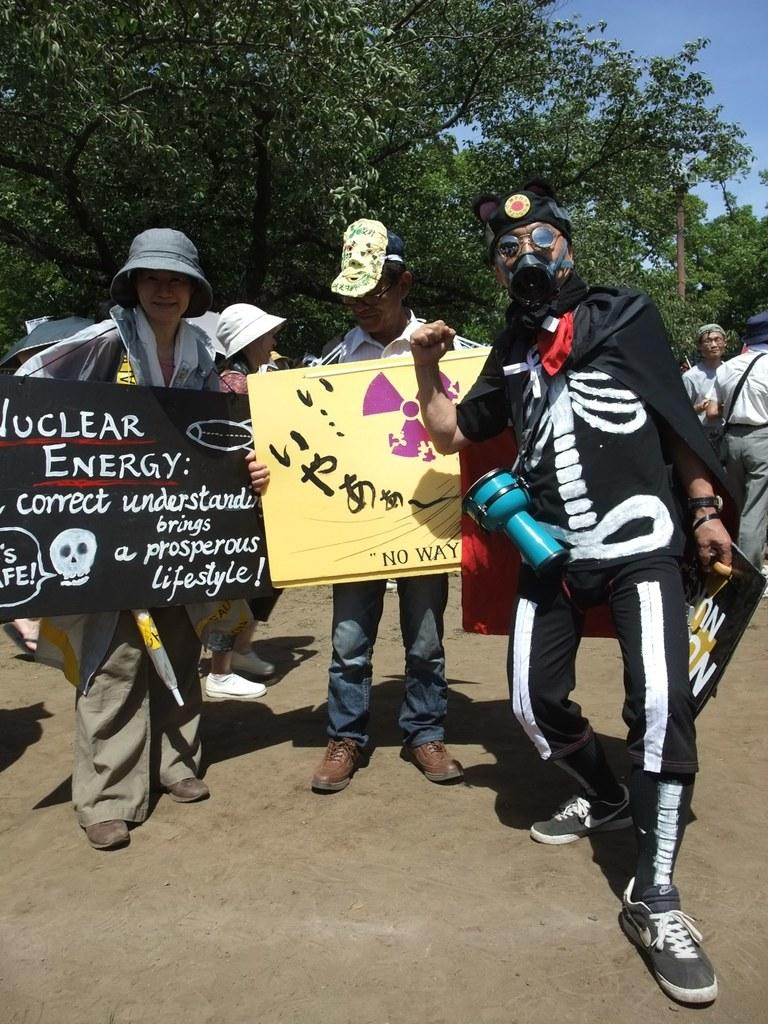What is happening in the image involving the group of people? There is a group of people on the ground in the image, and some of them are holding posters. What can be seen in the background of the image? There are trees, a pole, and the sky visible in the background of the image. What type of frame is surrounding the group of people in the image? There is no frame surrounding the group of people in the image. Can you see any gravestones or tombstones in the image? There is no cemetery or any gravestones or tombstones present in the image. 